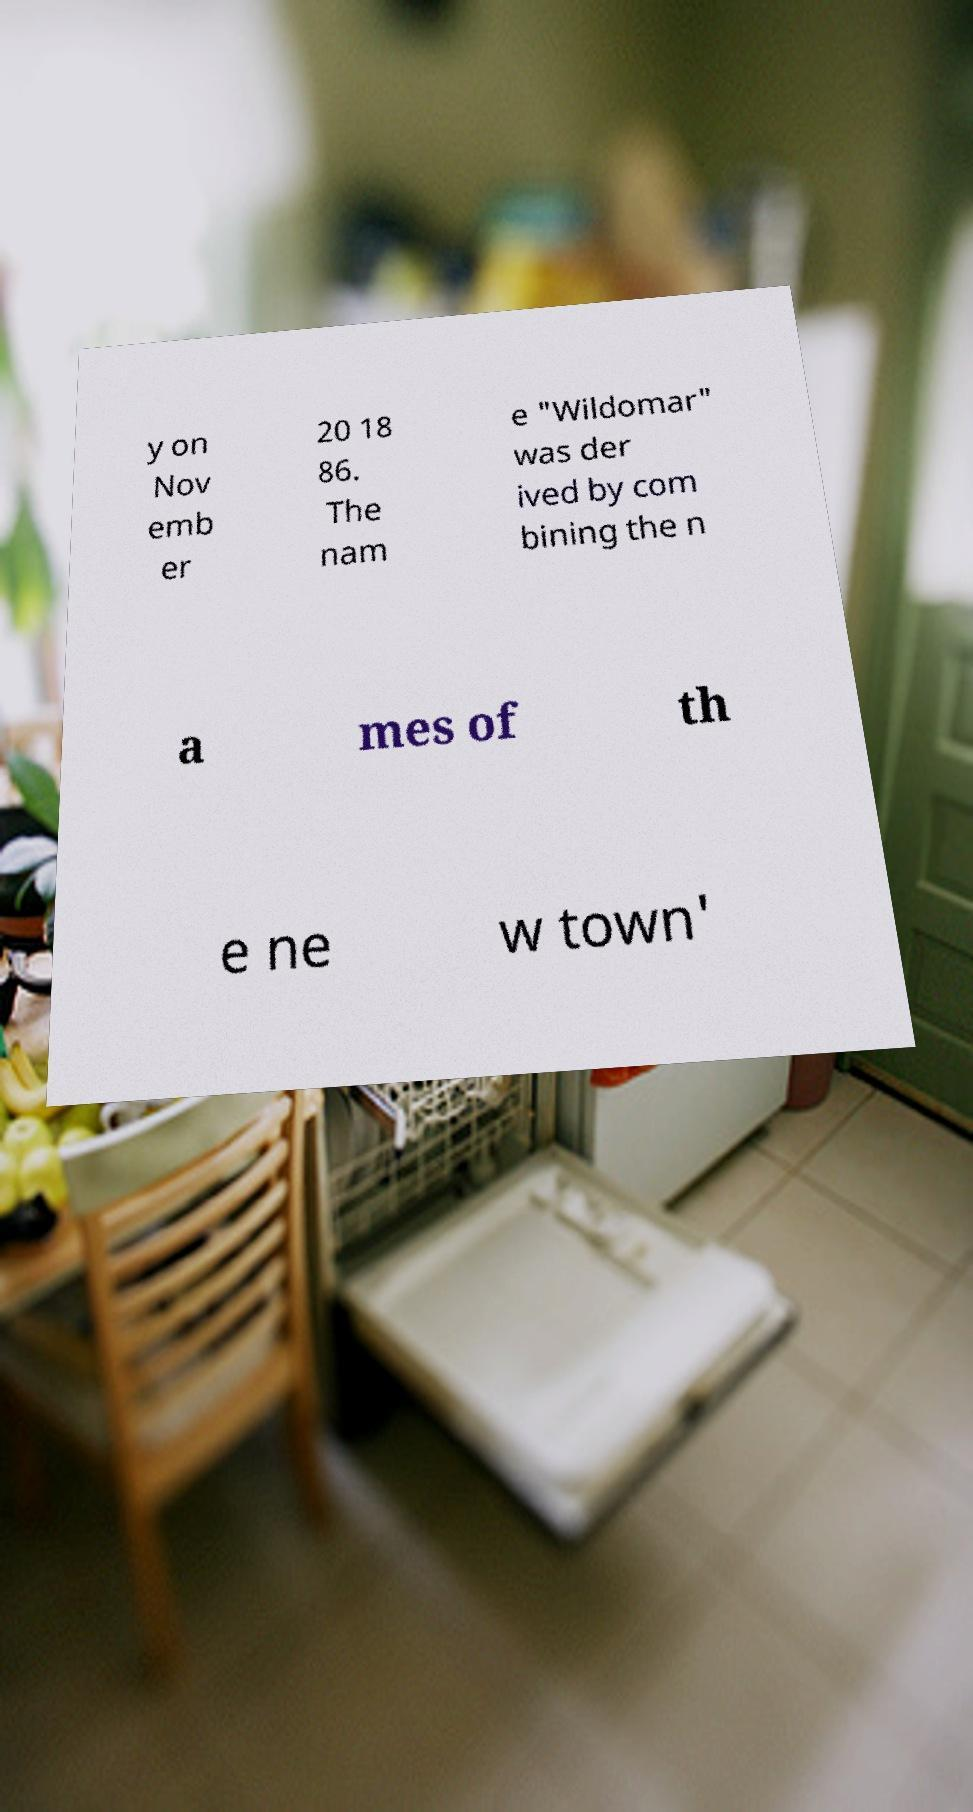Could you extract and type out the text from this image? y on Nov emb er 20 18 86. The nam e "Wildomar" was der ived by com bining the n a mes of th e ne w town' 